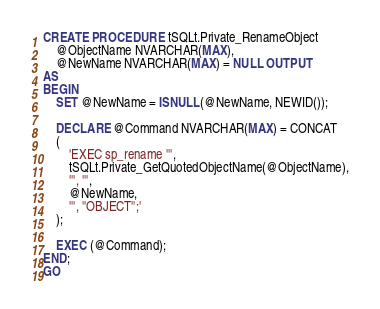<code> <loc_0><loc_0><loc_500><loc_500><_SQL_>CREATE PROCEDURE tSQLt.Private_RenameObject
    @ObjectName NVARCHAR(MAX),
    @NewName NVARCHAR(MAX) = NULL OUTPUT
AS
BEGIN
    SET @NewName = ISNULL(@NewName, NEWID());

    DECLARE @Command NVARCHAR(MAX) = CONCAT
    (
        'EXEC sp_rename ''',
        tSQLt.Private_GetQuotedObjectName(@ObjectName),
        ''', ''',
        @NewName,
        ''', ''OBJECT'';'
    );

    EXEC (@Command);
END;
GO</code> 